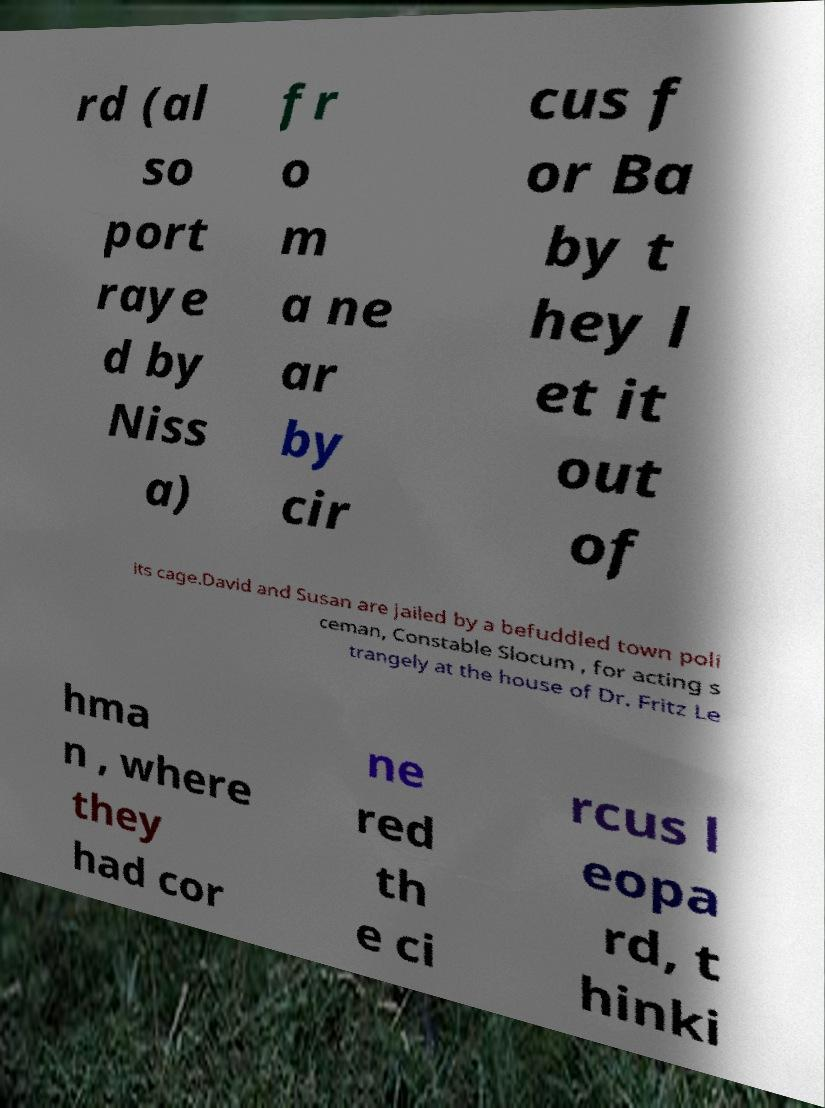Could you extract and type out the text from this image? rd (al so port raye d by Niss a) fr o m a ne ar by cir cus f or Ba by t hey l et it out of its cage.David and Susan are jailed by a befuddled town poli ceman, Constable Slocum , for acting s trangely at the house of Dr. Fritz Le hma n , where they had cor ne red th e ci rcus l eopa rd, t hinki 